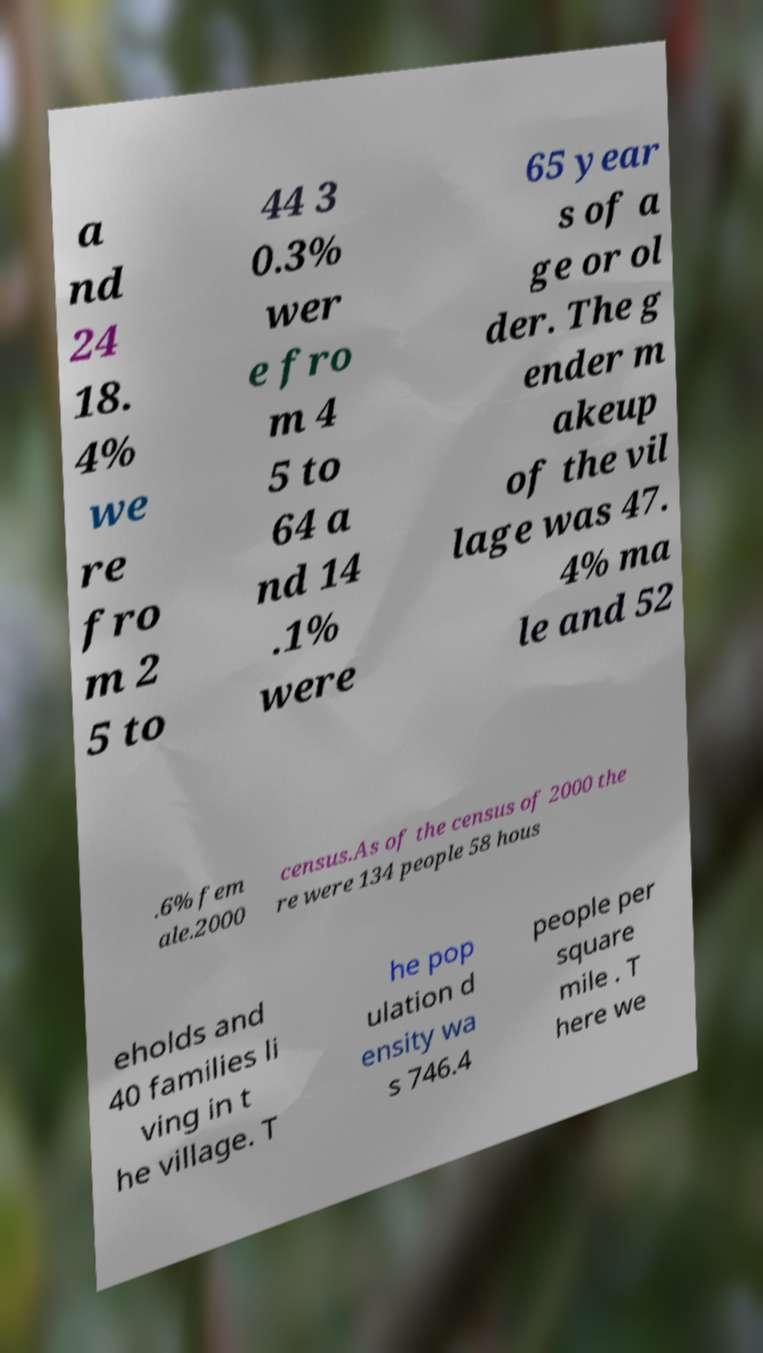Can you read and provide the text displayed in the image?This photo seems to have some interesting text. Can you extract and type it out for me? a nd 24 18. 4% we re fro m 2 5 to 44 3 0.3% wer e fro m 4 5 to 64 a nd 14 .1% were 65 year s of a ge or ol der. The g ender m akeup of the vil lage was 47. 4% ma le and 52 .6% fem ale.2000 census.As of the census of 2000 the re were 134 people 58 hous eholds and 40 families li ving in t he village. T he pop ulation d ensity wa s 746.4 people per square mile . T here we 